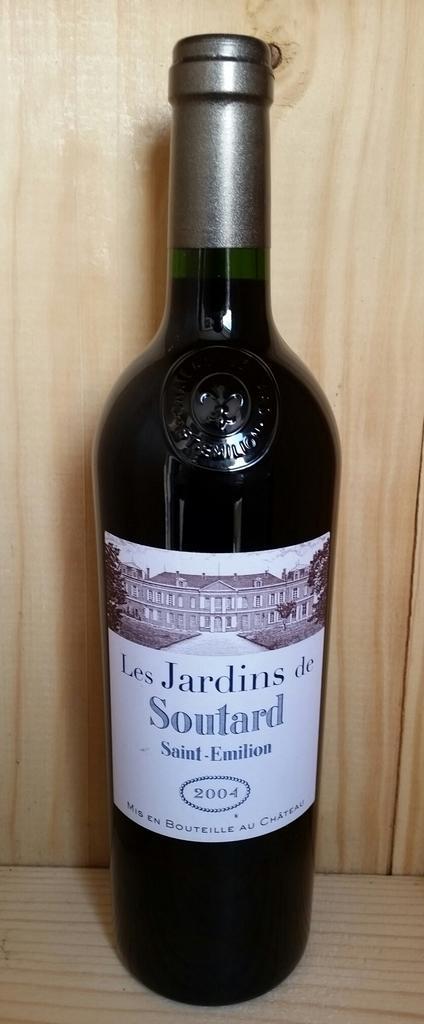Please provide a concise description of this image. In the center of the picture there is a wine bottle. In the background there is a wooden wall and a wooden foreground. 